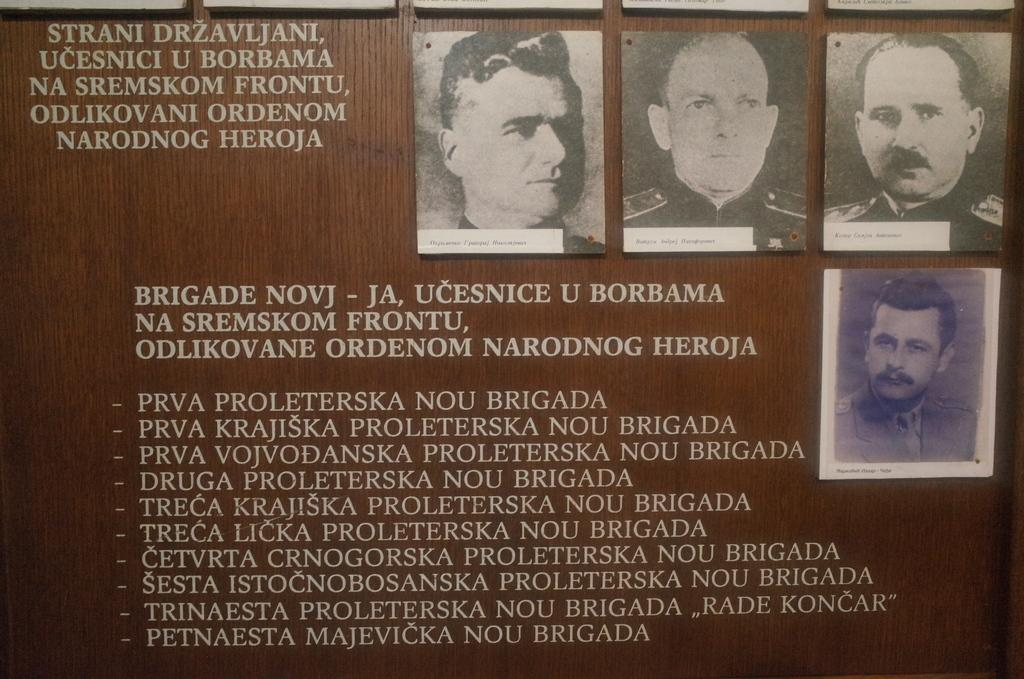What is the main object in the image? There is a notice board in the image. What can be found on the notice board? There are pictures and text on the notice board. What type of rod is used to hold the knowledge on the notice board? There is no rod mentioned in the image, and the term "knowledge" is not used to describe the content of the notice board. 